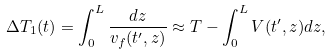<formula> <loc_0><loc_0><loc_500><loc_500>\Delta T _ { 1 } ( t ) = \int _ { 0 } ^ { L } \frac { d z } { v _ { f } ( t ^ { \prime } , z ) } \approx T - \int _ { 0 } ^ { L } V ( t ^ { \prime } , z ) d z ,</formula> 